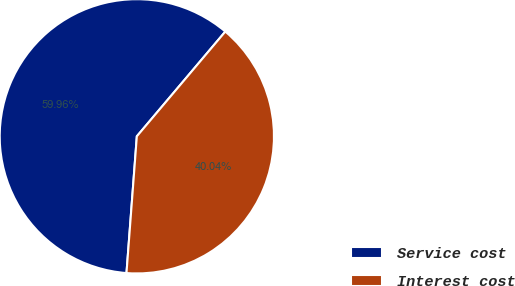<chart> <loc_0><loc_0><loc_500><loc_500><pie_chart><fcel>Service cost<fcel>Interest cost<nl><fcel>59.96%<fcel>40.04%<nl></chart> 